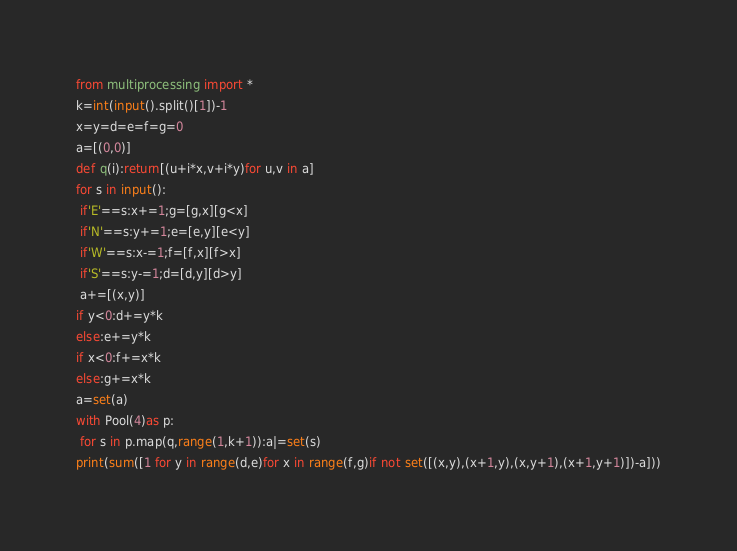Convert code to text. <code><loc_0><loc_0><loc_500><loc_500><_Python_>from multiprocessing import *
k=int(input().split()[1])-1
x=y=d=e=f=g=0
a=[(0,0)]
def q(i):return[(u+i*x,v+i*y)for u,v in a]
for s in input():
 if'E'==s:x+=1;g=[g,x][g<x]
 if'N'==s:y+=1;e=[e,y][e<y]
 if'W'==s:x-=1;f=[f,x][f>x]
 if'S'==s:y-=1;d=[d,y][d>y]
 a+=[(x,y)]
if y<0:d+=y*k
else:e+=y*k
if x<0:f+=x*k
else:g+=x*k
a=set(a)
with Pool(4)as p:
 for s in p.map(q,range(1,k+1)):a|=set(s)
print(sum([1 for y in range(d,e)for x in range(f,g)if not set([(x,y),(x+1,y),(x,y+1),(x+1,y+1)])-a]))
</code> 